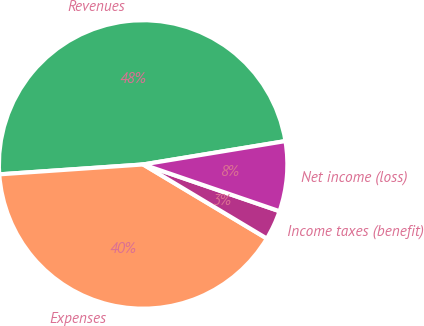<chart> <loc_0><loc_0><loc_500><loc_500><pie_chart><fcel>Revenues<fcel>Expenses<fcel>Income taxes (benefit)<fcel>Net income (loss)<nl><fcel>48.5%<fcel>40.32%<fcel>3.33%<fcel>7.85%<nl></chart> 